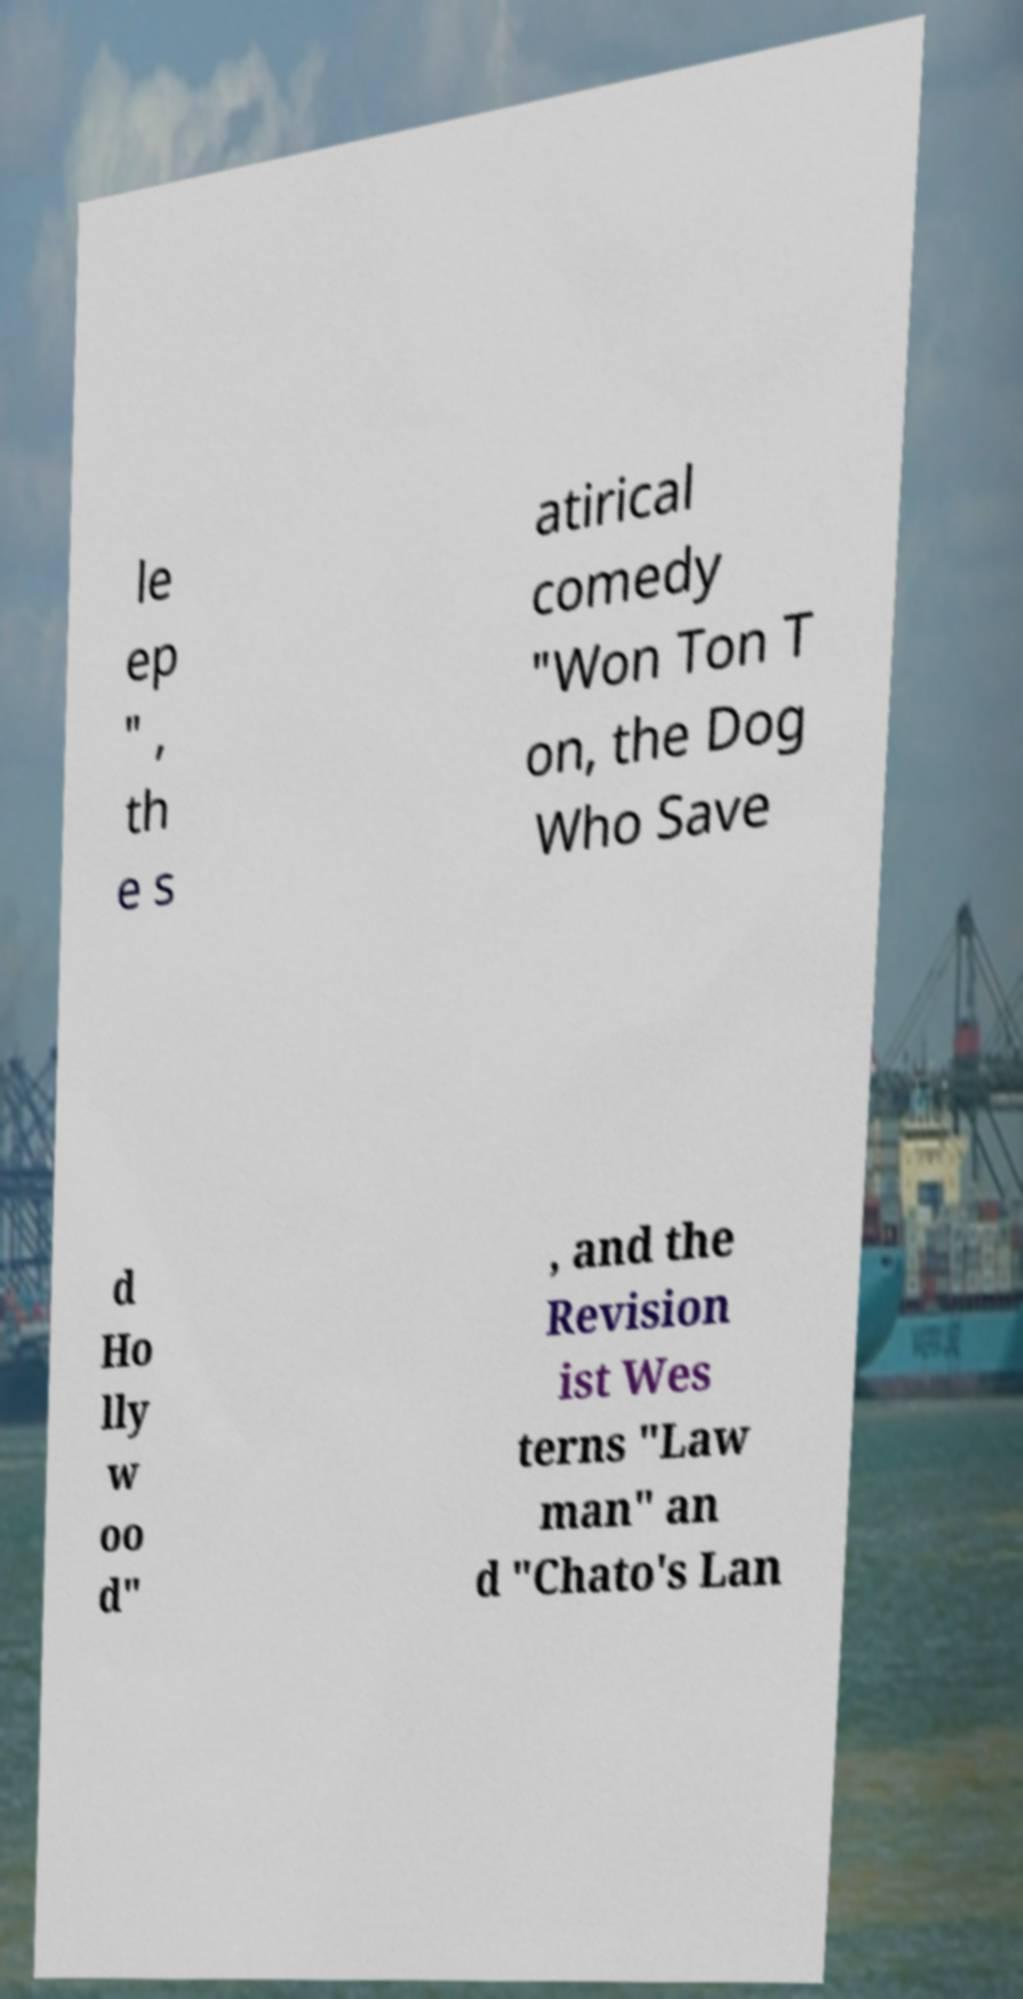Can you accurately transcribe the text from the provided image for me? le ep " , th e s atirical comedy "Won Ton T on, the Dog Who Save d Ho lly w oo d" , and the Revision ist Wes terns "Law man" an d "Chato's Lan 